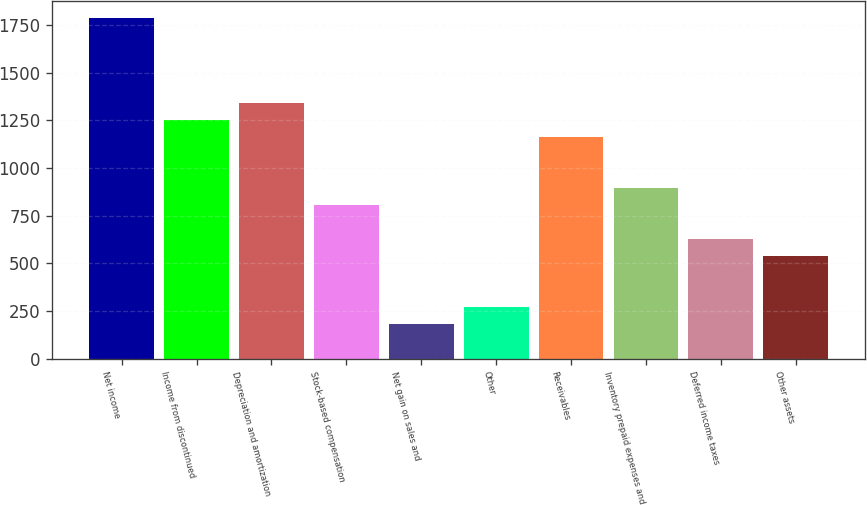Convert chart to OTSL. <chart><loc_0><loc_0><loc_500><loc_500><bar_chart><fcel>Net income<fcel>Income from discontinued<fcel>Depreciation and amortization<fcel>Stock-based compensation<fcel>Net gain on sales and<fcel>Other<fcel>Receivables<fcel>Inventory prepaid expenses and<fcel>Deferred income taxes<fcel>Other assets<nl><fcel>1786<fcel>1250.8<fcel>1340<fcel>804.8<fcel>180.4<fcel>269.6<fcel>1161.6<fcel>894<fcel>626.4<fcel>537.2<nl></chart> 